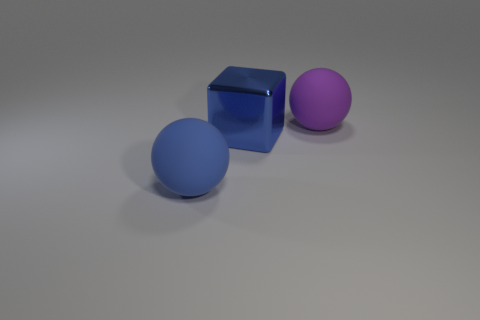Add 3 blue objects. How many objects exist? 6 Subtract all balls. How many objects are left? 1 Subtract all big red matte objects. Subtract all blue matte things. How many objects are left? 2 Add 2 big blue things. How many big blue things are left? 4 Add 3 blue shiny objects. How many blue shiny objects exist? 4 Subtract 0 yellow balls. How many objects are left? 3 